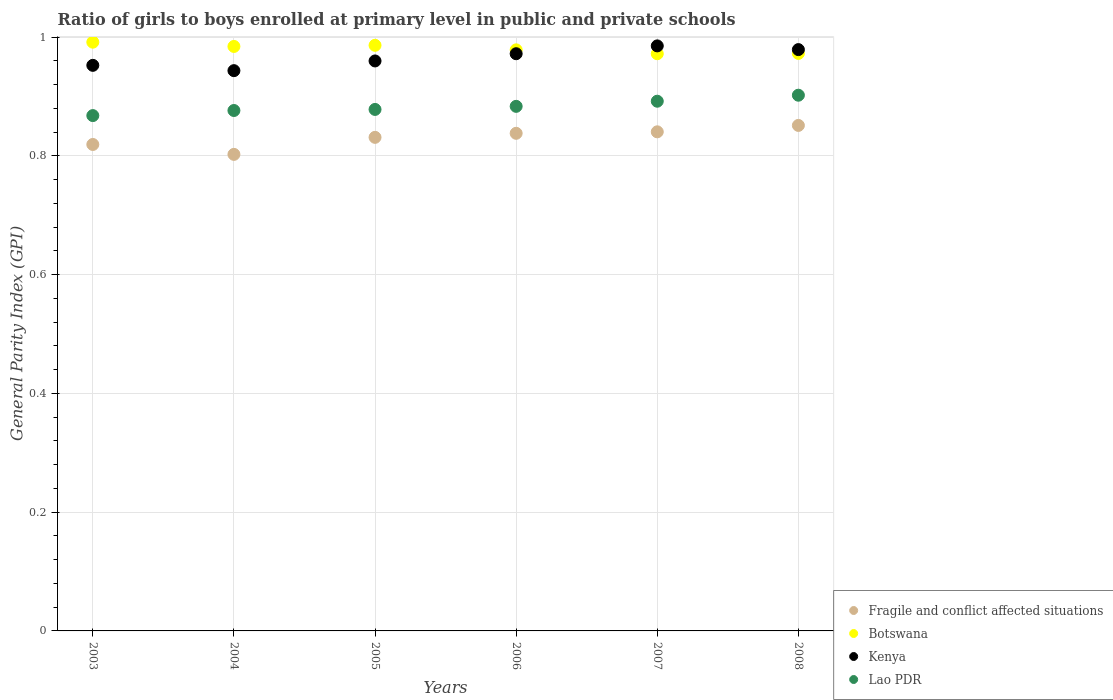What is the general parity index in Fragile and conflict affected situations in 2006?
Your answer should be compact. 0.84. Across all years, what is the maximum general parity index in Lao PDR?
Offer a terse response. 0.9. Across all years, what is the minimum general parity index in Botswana?
Keep it short and to the point. 0.97. In which year was the general parity index in Fragile and conflict affected situations maximum?
Make the answer very short. 2008. In which year was the general parity index in Botswana minimum?
Your response must be concise. 2007. What is the total general parity index in Lao PDR in the graph?
Provide a short and direct response. 5.3. What is the difference between the general parity index in Kenya in 2006 and that in 2007?
Keep it short and to the point. -0.01. What is the difference between the general parity index in Fragile and conflict affected situations in 2006 and the general parity index in Botswana in 2003?
Offer a terse response. -0.15. What is the average general parity index in Botswana per year?
Give a very brief answer. 0.98. In the year 2007, what is the difference between the general parity index in Kenya and general parity index in Botswana?
Ensure brevity in your answer.  0.01. What is the ratio of the general parity index in Kenya in 2005 to that in 2007?
Your answer should be compact. 0.97. Is the general parity index in Lao PDR in 2005 less than that in 2008?
Keep it short and to the point. Yes. What is the difference between the highest and the second highest general parity index in Botswana?
Your answer should be very brief. 0.01. What is the difference between the highest and the lowest general parity index in Lao PDR?
Provide a succinct answer. 0.03. In how many years, is the general parity index in Kenya greater than the average general parity index in Kenya taken over all years?
Your answer should be compact. 3. Is the sum of the general parity index in Botswana in 2006 and 2008 greater than the maximum general parity index in Kenya across all years?
Ensure brevity in your answer.  Yes. Is it the case that in every year, the sum of the general parity index in Kenya and general parity index in Lao PDR  is greater than the sum of general parity index in Fragile and conflict affected situations and general parity index in Botswana?
Make the answer very short. No. Is it the case that in every year, the sum of the general parity index in Fragile and conflict affected situations and general parity index in Kenya  is greater than the general parity index in Lao PDR?
Make the answer very short. Yes. Does the general parity index in Fragile and conflict affected situations monotonically increase over the years?
Make the answer very short. No. Is the general parity index in Kenya strictly greater than the general parity index in Lao PDR over the years?
Make the answer very short. Yes. How many dotlines are there?
Ensure brevity in your answer.  4. Are the values on the major ticks of Y-axis written in scientific E-notation?
Give a very brief answer. No. Does the graph contain grids?
Provide a short and direct response. Yes. What is the title of the graph?
Your answer should be very brief. Ratio of girls to boys enrolled at primary level in public and private schools. Does "Haiti" appear as one of the legend labels in the graph?
Provide a succinct answer. No. What is the label or title of the X-axis?
Give a very brief answer. Years. What is the label or title of the Y-axis?
Keep it short and to the point. General Parity Index (GPI). What is the General Parity Index (GPI) in Fragile and conflict affected situations in 2003?
Ensure brevity in your answer.  0.82. What is the General Parity Index (GPI) of Botswana in 2003?
Your response must be concise. 0.99. What is the General Parity Index (GPI) in Kenya in 2003?
Keep it short and to the point. 0.95. What is the General Parity Index (GPI) of Lao PDR in 2003?
Offer a very short reply. 0.87. What is the General Parity Index (GPI) in Fragile and conflict affected situations in 2004?
Ensure brevity in your answer.  0.8. What is the General Parity Index (GPI) of Botswana in 2004?
Your answer should be compact. 0.98. What is the General Parity Index (GPI) in Kenya in 2004?
Provide a short and direct response. 0.94. What is the General Parity Index (GPI) of Lao PDR in 2004?
Make the answer very short. 0.88. What is the General Parity Index (GPI) in Fragile and conflict affected situations in 2005?
Offer a terse response. 0.83. What is the General Parity Index (GPI) in Botswana in 2005?
Give a very brief answer. 0.99. What is the General Parity Index (GPI) in Kenya in 2005?
Provide a short and direct response. 0.96. What is the General Parity Index (GPI) of Lao PDR in 2005?
Provide a short and direct response. 0.88. What is the General Parity Index (GPI) in Fragile and conflict affected situations in 2006?
Make the answer very short. 0.84. What is the General Parity Index (GPI) of Botswana in 2006?
Your answer should be very brief. 0.98. What is the General Parity Index (GPI) of Kenya in 2006?
Your answer should be very brief. 0.97. What is the General Parity Index (GPI) of Lao PDR in 2006?
Your answer should be very brief. 0.88. What is the General Parity Index (GPI) of Fragile and conflict affected situations in 2007?
Make the answer very short. 0.84. What is the General Parity Index (GPI) in Botswana in 2007?
Offer a very short reply. 0.97. What is the General Parity Index (GPI) of Kenya in 2007?
Offer a terse response. 0.99. What is the General Parity Index (GPI) in Lao PDR in 2007?
Your response must be concise. 0.89. What is the General Parity Index (GPI) in Fragile and conflict affected situations in 2008?
Make the answer very short. 0.85. What is the General Parity Index (GPI) in Botswana in 2008?
Offer a terse response. 0.97. What is the General Parity Index (GPI) of Kenya in 2008?
Make the answer very short. 0.98. What is the General Parity Index (GPI) in Lao PDR in 2008?
Your response must be concise. 0.9. Across all years, what is the maximum General Parity Index (GPI) in Fragile and conflict affected situations?
Offer a very short reply. 0.85. Across all years, what is the maximum General Parity Index (GPI) of Botswana?
Offer a terse response. 0.99. Across all years, what is the maximum General Parity Index (GPI) of Kenya?
Ensure brevity in your answer.  0.99. Across all years, what is the maximum General Parity Index (GPI) in Lao PDR?
Ensure brevity in your answer.  0.9. Across all years, what is the minimum General Parity Index (GPI) of Fragile and conflict affected situations?
Your answer should be compact. 0.8. Across all years, what is the minimum General Parity Index (GPI) in Botswana?
Your answer should be compact. 0.97. Across all years, what is the minimum General Parity Index (GPI) in Kenya?
Offer a very short reply. 0.94. Across all years, what is the minimum General Parity Index (GPI) of Lao PDR?
Offer a very short reply. 0.87. What is the total General Parity Index (GPI) of Fragile and conflict affected situations in the graph?
Make the answer very short. 4.98. What is the total General Parity Index (GPI) of Botswana in the graph?
Your response must be concise. 5.89. What is the total General Parity Index (GPI) of Kenya in the graph?
Provide a short and direct response. 5.79. What is the total General Parity Index (GPI) of Lao PDR in the graph?
Your answer should be compact. 5.3. What is the difference between the General Parity Index (GPI) in Fragile and conflict affected situations in 2003 and that in 2004?
Provide a short and direct response. 0.02. What is the difference between the General Parity Index (GPI) of Botswana in 2003 and that in 2004?
Provide a short and direct response. 0.01. What is the difference between the General Parity Index (GPI) of Kenya in 2003 and that in 2004?
Your answer should be compact. 0.01. What is the difference between the General Parity Index (GPI) in Lao PDR in 2003 and that in 2004?
Offer a very short reply. -0.01. What is the difference between the General Parity Index (GPI) of Fragile and conflict affected situations in 2003 and that in 2005?
Provide a short and direct response. -0.01. What is the difference between the General Parity Index (GPI) in Botswana in 2003 and that in 2005?
Make the answer very short. 0.01. What is the difference between the General Parity Index (GPI) of Kenya in 2003 and that in 2005?
Your answer should be very brief. -0.01. What is the difference between the General Parity Index (GPI) in Lao PDR in 2003 and that in 2005?
Provide a succinct answer. -0.01. What is the difference between the General Parity Index (GPI) of Fragile and conflict affected situations in 2003 and that in 2006?
Your response must be concise. -0.02. What is the difference between the General Parity Index (GPI) of Botswana in 2003 and that in 2006?
Your response must be concise. 0.01. What is the difference between the General Parity Index (GPI) of Kenya in 2003 and that in 2006?
Your answer should be compact. -0.02. What is the difference between the General Parity Index (GPI) of Lao PDR in 2003 and that in 2006?
Provide a succinct answer. -0.02. What is the difference between the General Parity Index (GPI) of Fragile and conflict affected situations in 2003 and that in 2007?
Make the answer very short. -0.02. What is the difference between the General Parity Index (GPI) in Botswana in 2003 and that in 2007?
Give a very brief answer. 0.02. What is the difference between the General Parity Index (GPI) in Kenya in 2003 and that in 2007?
Your answer should be very brief. -0.03. What is the difference between the General Parity Index (GPI) of Lao PDR in 2003 and that in 2007?
Ensure brevity in your answer.  -0.02. What is the difference between the General Parity Index (GPI) of Fragile and conflict affected situations in 2003 and that in 2008?
Provide a short and direct response. -0.03. What is the difference between the General Parity Index (GPI) in Botswana in 2003 and that in 2008?
Provide a succinct answer. 0.02. What is the difference between the General Parity Index (GPI) in Kenya in 2003 and that in 2008?
Give a very brief answer. -0.03. What is the difference between the General Parity Index (GPI) of Lao PDR in 2003 and that in 2008?
Provide a succinct answer. -0.03. What is the difference between the General Parity Index (GPI) of Fragile and conflict affected situations in 2004 and that in 2005?
Your answer should be compact. -0.03. What is the difference between the General Parity Index (GPI) of Botswana in 2004 and that in 2005?
Keep it short and to the point. -0. What is the difference between the General Parity Index (GPI) in Kenya in 2004 and that in 2005?
Provide a short and direct response. -0.02. What is the difference between the General Parity Index (GPI) in Lao PDR in 2004 and that in 2005?
Give a very brief answer. -0. What is the difference between the General Parity Index (GPI) in Fragile and conflict affected situations in 2004 and that in 2006?
Ensure brevity in your answer.  -0.04. What is the difference between the General Parity Index (GPI) in Botswana in 2004 and that in 2006?
Offer a very short reply. 0.01. What is the difference between the General Parity Index (GPI) in Kenya in 2004 and that in 2006?
Give a very brief answer. -0.03. What is the difference between the General Parity Index (GPI) in Lao PDR in 2004 and that in 2006?
Give a very brief answer. -0.01. What is the difference between the General Parity Index (GPI) in Fragile and conflict affected situations in 2004 and that in 2007?
Your response must be concise. -0.04. What is the difference between the General Parity Index (GPI) of Botswana in 2004 and that in 2007?
Your answer should be compact. 0.01. What is the difference between the General Parity Index (GPI) of Kenya in 2004 and that in 2007?
Keep it short and to the point. -0.04. What is the difference between the General Parity Index (GPI) of Lao PDR in 2004 and that in 2007?
Provide a short and direct response. -0.02. What is the difference between the General Parity Index (GPI) in Fragile and conflict affected situations in 2004 and that in 2008?
Give a very brief answer. -0.05. What is the difference between the General Parity Index (GPI) of Botswana in 2004 and that in 2008?
Ensure brevity in your answer.  0.01. What is the difference between the General Parity Index (GPI) in Kenya in 2004 and that in 2008?
Offer a terse response. -0.04. What is the difference between the General Parity Index (GPI) in Lao PDR in 2004 and that in 2008?
Keep it short and to the point. -0.03. What is the difference between the General Parity Index (GPI) of Fragile and conflict affected situations in 2005 and that in 2006?
Your answer should be compact. -0.01. What is the difference between the General Parity Index (GPI) of Botswana in 2005 and that in 2006?
Provide a short and direct response. 0.01. What is the difference between the General Parity Index (GPI) of Kenya in 2005 and that in 2006?
Offer a terse response. -0.01. What is the difference between the General Parity Index (GPI) of Lao PDR in 2005 and that in 2006?
Provide a succinct answer. -0.01. What is the difference between the General Parity Index (GPI) of Fragile and conflict affected situations in 2005 and that in 2007?
Give a very brief answer. -0.01. What is the difference between the General Parity Index (GPI) of Botswana in 2005 and that in 2007?
Give a very brief answer. 0.01. What is the difference between the General Parity Index (GPI) in Kenya in 2005 and that in 2007?
Keep it short and to the point. -0.03. What is the difference between the General Parity Index (GPI) of Lao PDR in 2005 and that in 2007?
Your response must be concise. -0.01. What is the difference between the General Parity Index (GPI) in Fragile and conflict affected situations in 2005 and that in 2008?
Make the answer very short. -0.02. What is the difference between the General Parity Index (GPI) of Botswana in 2005 and that in 2008?
Provide a short and direct response. 0.01. What is the difference between the General Parity Index (GPI) in Kenya in 2005 and that in 2008?
Provide a short and direct response. -0.02. What is the difference between the General Parity Index (GPI) of Lao PDR in 2005 and that in 2008?
Provide a succinct answer. -0.02. What is the difference between the General Parity Index (GPI) in Fragile and conflict affected situations in 2006 and that in 2007?
Your answer should be compact. -0. What is the difference between the General Parity Index (GPI) in Botswana in 2006 and that in 2007?
Your answer should be compact. 0.01. What is the difference between the General Parity Index (GPI) of Kenya in 2006 and that in 2007?
Provide a short and direct response. -0.01. What is the difference between the General Parity Index (GPI) of Lao PDR in 2006 and that in 2007?
Ensure brevity in your answer.  -0.01. What is the difference between the General Parity Index (GPI) of Fragile and conflict affected situations in 2006 and that in 2008?
Offer a very short reply. -0.01. What is the difference between the General Parity Index (GPI) of Botswana in 2006 and that in 2008?
Give a very brief answer. 0.01. What is the difference between the General Parity Index (GPI) of Kenya in 2006 and that in 2008?
Your answer should be very brief. -0.01. What is the difference between the General Parity Index (GPI) in Lao PDR in 2006 and that in 2008?
Your answer should be very brief. -0.02. What is the difference between the General Parity Index (GPI) of Fragile and conflict affected situations in 2007 and that in 2008?
Your answer should be compact. -0.01. What is the difference between the General Parity Index (GPI) in Botswana in 2007 and that in 2008?
Give a very brief answer. -0. What is the difference between the General Parity Index (GPI) of Kenya in 2007 and that in 2008?
Offer a terse response. 0.01. What is the difference between the General Parity Index (GPI) of Lao PDR in 2007 and that in 2008?
Your answer should be compact. -0.01. What is the difference between the General Parity Index (GPI) of Fragile and conflict affected situations in 2003 and the General Parity Index (GPI) of Botswana in 2004?
Provide a short and direct response. -0.17. What is the difference between the General Parity Index (GPI) of Fragile and conflict affected situations in 2003 and the General Parity Index (GPI) of Kenya in 2004?
Your answer should be compact. -0.12. What is the difference between the General Parity Index (GPI) of Fragile and conflict affected situations in 2003 and the General Parity Index (GPI) of Lao PDR in 2004?
Your response must be concise. -0.06. What is the difference between the General Parity Index (GPI) in Botswana in 2003 and the General Parity Index (GPI) in Kenya in 2004?
Provide a short and direct response. 0.05. What is the difference between the General Parity Index (GPI) in Botswana in 2003 and the General Parity Index (GPI) in Lao PDR in 2004?
Provide a short and direct response. 0.12. What is the difference between the General Parity Index (GPI) in Kenya in 2003 and the General Parity Index (GPI) in Lao PDR in 2004?
Provide a short and direct response. 0.08. What is the difference between the General Parity Index (GPI) in Fragile and conflict affected situations in 2003 and the General Parity Index (GPI) in Botswana in 2005?
Provide a short and direct response. -0.17. What is the difference between the General Parity Index (GPI) in Fragile and conflict affected situations in 2003 and the General Parity Index (GPI) in Kenya in 2005?
Offer a terse response. -0.14. What is the difference between the General Parity Index (GPI) of Fragile and conflict affected situations in 2003 and the General Parity Index (GPI) of Lao PDR in 2005?
Offer a very short reply. -0.06. What is the difference between the General Parity Index (GPI) of Botswana in 2003 and the General Parity Index (GPI) of Kenya in 2005?
Ensure brevity in your answer.  0.03. What is the difference between the General Parity Index (GPI) in Botswana in 2003 and the General Parity Index (GPI) in Lao PDR in 2005?
Provide a short and direct response. 0.11. What is the difference between the General Parity Index (GPI) in Kenya in 2003 and the General Parity Index (GPI) in Lao PDR in 2005?
Provide a succinct answer. 0.07. What is the difference between the General Parity Index (GPI) in Fragile and conflict affected situations in 2003 and the General Parity Index (GPI) in Botswana in 2006?
Give a very brief answer. -0.16. What is the difference between the General Parity Index (GPI) in Fragile and conflict affected situations in 2003 and the General Parity Index (GPI) in Kenya in 2006?
Ensure brevity in your answer.  -0.15. What is the difference between the General Parity Index (GPI) in Fragile and conflict affected situations in 2003 and the General Parity Index (GPI) in Lao PDR in 2006?
Provide a short and direct response. -0.06. What is the difference between the General Parity Index (GPI) of Botswana in 2003 and the General Parity Index (GPI) of Kenya in 2006?
Provide a succinct answer. 0.02. What is the difference between the General Parity Index (GPI) in Botswana in 2003 and the General Parity Index (GPI) in Lao PDR in 2006?
Ensure brevity in your answer.  0.11. What is the difference between the General Parity Index (GPI) of Kenya in 2003 and the General Parity Index (GPI) of Lao PDR in 2006?
Ensure brevity in your answer.  0.07. What is the difference between the General Parity Index (GPI) of Fragile and conflict affected situations in 2003 and the General Parity Index (GPI) of Botswana in 2007?
Offer a very short reply. -0.15. What is the difference between the General Parity Index (GPI) of Fragile and conflict affected situations in 2003 and the General Parity Index (GPI) of Kenya in 2007?
Your answer should be very brief. -0.17. What is the difference between the General Parity Index (GPI) in Fragile and conflict affected situations in 2003 and the General Parity Index (GPI) in Lao PDR in 2007?
Your response must be concise. -0.07. What is the difference between the General Parity Index (GPI) in Botswana in 2003 and the General Parity Index (GPI) in Kenya in 2007?
Give a very brief answer. 0.01. What is the difference between the General Parity Index (GPI) of Botswana in 2003 and the General Parity Index (GPI) of Lao PDR in 2007?
Provide a short and direct response. 0.1. What is the difference between the General Parity Index (GPI) in Kenya in 2003 and the General Parity Index (GPI) in Lao PDR in 2007?
Offer a very short reply. 0.06. What is the difference between the General Parity Index (GPI) of Fragile and conflict affected situations in 2003 and the General Parity Index (GPI) of Botswana in 2008?
Provide a succinct answer. -0.15. What is the difference between the General Parity Index (GPI) of Fragile and conflict affected situations in 2003 and the General Parity Index (GPI) of Kenya in 2008?
Your answer should be very brief. -0.16. What is the difference between the General Parity Index (GPI) of Fragile and conflict affected situations in 2003 and the General Parity Index (GPI) of Lao PDR in 2008?
Make the answer very short. -0.08. What is the difference between the General Parity Index (GPI) in Botswana in 2003 and the General Parity Index (GPI) in Kenya in 2008?
Provide a short and direct response. 0.01. What is the difference between the General Parity Index (GPI) in Botswana in 2003 and the General Parity Index (GPI) in Lao PDR in 2008?
Provide a succinct answer. 0.09. What is the difference between the General Parity Index (GPI) in Kenya in 2003 and the General Parity Index (GPI) in Lao PDR in 2008?
Your response must be concise. 0.05. What is the difference between the General Parity Index (GPI) of Fragile and conflict affected situations in 2004 and the General Parity Index (GPI) of Botswana in 2005?
Offer a terse response. -0.18. What is the difference between the General Parity Index (GPI) of Fragile and conflict affected situations in 2004 and the General Parity Index (GPI) of Kenya in 2005?
Offer a very short reply. -0.16. What is the difference between the General Parity Index (GPI) in Fragile and conflict affected situations in 2004 and the General Parity Index (GPI) in Lao PDR in 2005?
Make the answer very short. -0.08. What is the difference between the General Parity Index (GPI) in Botswana in 2004 and the General Parity Index (GPI) in Kenya in 2005?
Provide a succinct answer. 0.02. What is the difference between the General Parity Index (GPI) in Botswana in 2004 and the General Parity Index (GPI) in Lao PDR in 2005?
Your answer should be compact. 0.11. What is the difference between the General Parity Index (GPI) of Kenya in 2004 and the General Parity Index (GPI) of Lao PDR in 2005?
Keep it short and to the point. 0.07. What is the difference between the General Parity Index (GPI) in Fragile and conflict affected situations in 2004 and the General Parity Index (GPI) in Botswana in 2006?
Offer a terse response. -0.18. What is the difference between the General Parity Index (GPI) in Fragile and conflict affected situations in 2004 and the General Parity Index (GPI) in Kenya in 2006?
Make the answer very short. -0.17. What is the difference between the General Parity Index (GPI) of Fragile and conflict affected situations in 2004 and the General Parity Index (GPI) of Lao PDR in 2006?
Your answer should be compact. -0.08. What is the difference between the General Parity Index (GPI) in Botswana in 2004 and the General Parity Index (GPI) in Kenya in 2006?
Your response must be concise. 0.01. What is the difference between the General Parity Index (GPI) in Botswana in 2004 and the General Parity Index (GPI) in Lao PDR in 2006?
Your response must be concise. 0.1. What is the difference between the General Parity Index (GPI) of Kenya in 2004 and the General Parity Index (GPI) of Lao PDR in 2006?
Offer a terse response. 0.06. What is the difference between the General Parity Index (GPI) of Fragile and conflict affected situations in 2004 and the General Parity Index (GPI) of Botswana in 2007?
Offer a terse response. -0.17. What is the difference between the General Parity Index (GPI) in Fragile and conflict affected situations in 2004 and the General Parity Index (GPI) in Kenya in 2007?
Your response must be concise. -0.18. What is the difference between the General Parity Index (GPI) of Fragile and conflict affected situations in 2004 and the General Parity Index (GPI) of Lao PDR in 2007?
Offer a very short reply. -0.09. What is the difference between the General Parity Index (GPI) in Botswana in 2004 and the General Parity Index (GPI) in Kenya in 2007?
Your response must be concise. -0. What is the difference between the General Parity Index (GPI) in Botswana in 2004 and the General Parity Index (GPI) in Lao PDR in 2007?
Make the answer very short. 0.09. What is the difference between the General Parity Index (GPI) in Kenya in 2004 and the General Parity Index (GPI) in Lao PDR in 2007?
Your response must be concise. 0.05. What is the difference between the General Parity Index (GPI) in Fragile and conflict affected situations in 2004 and the General Parity Index (GPI) in Botswana in 2008?
Offer a very short reply. -0.17. What is the difference between the General Parity Index (GPI) in Fragile and conflict affected situations in 2004 and the General Parity Index (GPI) in Kenya in 2008?
Provide a short and direct response. -0.18. What is the difference between the General Parity Index (GPI) of Fragile and conflict affected situations in 2004 and the General Parity Index (GPI) of Lao PDR in 2008?
Keep it short and to the point. -0.1. What is the difference between the General Parity Index (GPI) in Botswana in 2004 and the General Parity Index (GPI) in Kenya in 2008?
Offer a very short reply. 0.01. What is the difference between the General Parity Index (GPI) of Botswana in 2004 and the General Parity Index (GPI) of Lao PDR in 2008?
Keep it short and to the point. 0.08. What is the difference between the General Parity Index (GPI) in Kenya in 2004 and the General Parity Index (GPI) in Lao PDR in 2008?
Your answer should be very brief. 0.04. What is the difference between the General Parity Index (GPI) in Fragile and conflict affected situations in 2005 and the General Parity Index (GPI) in Botswana in 2006?
Your answer should be very brief. -0.15. What is the difference between the General Parity Index (GPI) of Fragile and conflict affected situations in 2005 and the General Parity Index (GPI) of Kenya in 2006?
Make the answer very short. -0.14. What is the difference between the General Parity Index (GPI) of Fragile and conflict affected situations in 2005 and the General Parity Index (GPI) of Lao PDR in 2006?
Ensure brevity in your answer.  -0.05. What is the difference between the General Parity Index (GPI) of Botswana in 2005 and the General Parity Index (GPI) of Kenya in 2006?
Provide a succinct answer. 0.01. What is the difference between the General Parity Index (GPI) of Botswana in 2005 and the General Parity Index (GPI) of Lao PDR in 2006?
Keep it short and to the point. 0.1. What is the difference between the General Parity Index (GPI) in Kenya in 2005 and the General Parity Index (GPI) in Lao PDR in 2006?
Your answer should be compact. 0.08. What is the difference between the General Parity Index (GPI) of Fragile and conflict affected situations in 2005 and the General Parity Index (GPI) of Botswana in 2007?
Your response must be concise. -0.14. What is the difference between the General Parity Index (GPI) of Fragile and conflict affected situations in 2005 and the General Parity Index (GPI) of Kenya in 2007?
Provide a succinct answer. -0.15. What is the difference between the General Parity Index (GPI) of Fragile and conflict affected situations in 2005 and the General Parity Index (GPI) of Lao PDR in 2007?
Make the answer very short. -0.06. What is the difference between the General Parity Index (GPI) in Botswana in 2005 and the General Parity Index (GPI) in Lao PDR in 2007?
Your answer should be compact. 0.09. What is the difference between the General Parity Index (GPI) in Kenya in 2005 and the General Parity Index (GPI) in Lao PDR in 2007?
Offer a very short reply. 0.07. What is the difference between the General Parity Index (GPI) in Fragile and conflict affected situations in 2005 and the General Parity Index (GPI) in Botswana in 2008?
Provide a succinct answer. -0.14. What is the difference between the General Parity Index (GPI) in Fragile and conflict affected situations in 2005 and the General Parity Index (GPI) in Kenya in 2008?
Your answer should be compact. -0.15. What is the difference between the General Parity Index (GPI) of Fragile and conflict affected situations in 2005 and the General Parity Index (GPI) of Lao PDR in 2008?
Offer a terse response. -0.07. What is the difference between the General Parity Index (GPI) of Botswana in 2005 and the General Parity Index (GPI) of Kenya in 2008?
Provide a succinct answer. 0.01. What is the difference between the General Parity Index (GPI) in Botswana in 2005 and the General Parity Index (GPI) in Lao PDR in 2008?
Your answer should be compact. 0.08. What is the difference between the General Parity Index (GPI) in Kenya in 2005 and the General Parity Index (GPI) in Lao PDR in 2008?
Make the answer very short. 0.06. What is the difference between the General Parity Index (GPI) in Fragile and conflict affected situations in 2006 and the General Parity Index (GPI) in Botswana in 2007?
Your response must be concise. -0.13. What is the difference between the General Parity Index (GPI) in Fragile and conflict affected situations in 2006 and the General Parity Index (GPI) in Kenya in 2007?
Your response must be concise. -0.15. What is the difference between the General Parity Index (GPI) in Fragile and conflict affected situations in 2006 and the General Parity Index (GPI) in Lao PDR in 2007?
Keep it short and to the point. -0.05. What is the difference between the General Parity Index (GPI) in Botswana in 2006 and the General Parity Index (GPI) in Kenya in 2007?
Provide a short and direct response. -0.01. What is the difference between the General Parity Index (GPI) in Botswana in 2006 and the General Parity Index (GPI) in Lao PDR in 2007?
Make the answer very short. 0.09. What is the difference between the General Parity Index (GPI) in Kenya in 2006 and the General Parity Index (GPI) in Lao PDR in 2007?
Offer a very short reply. 0.08. What is the difference between the General Parity Index (GPI) of Fragile and conflict affected situations in 2006 and the General Parity Index (GPI) of Botswana in 2008?
Offer a terse response. -0.13. What is the difference between the General Parity Index (GPI) of Fragile and conflict affected situations in 2006 and the General Parity Index (GPI) of Kenya in 2008?
Keep it short and to the point. -0.14. What is the difference between the General Parity Index (GPI) in Fragile and conflict affected situations in 2006 and the General Parity Index (GPI) in Lao PDR in 2008?
Provide a short and direct response. -0.06. What is the difference between the General Parity Index (GPI) of Botswana in 2006 and the General Parity Index (GPI) of Kenya in 2008?
Provide a succinct answer. -0. What is the difference between the General Parity Index (GPI) in Botswana in 2006 and the General Parity Index (GPI) in Lao PDR in 2008?
Give a very brief answer. 0.08. What is the difference between the General Parity Index (GPI) in Kenya in 2006 and the General Parity Index (GPI) in Lao PDR in 2008?
Keep it short and to the point. 0.07. What is the difference between the General Parity Index (GPI) of Fragile and conflict affected situations in 2007 and the General Parity Index (GPI) of Botswana in 2008?
Offer a terse response. -0.13. What is the difference between the General Parity Index (GPI) in Fragile and conflict affected situations in 2007 and the General Parity Index (GPI) in Kenya in 2008?
Ensure brevity in your answer.  -0.14. What is the difference between the General Parity Index (GPI) in Fragile and conflict affected situations in 2007 and the General Parity Index (GPI) in Lao PDR in 2008?
Provide a short and direct response. -0.06. What is the difference between the General Parity Index (GPI) in Botswana in 2007 and the General Parity Index (GPI) in Kenya in 2008?
Your answer should be very brief. -0.01. What is the difference between the General Parity Index (GPI) in Botswana in 2007 and the General Parity Index (GPI) in Lao PDR in 2008?
Offer a very short reply. 0.07. What is the difference between the General Parity Index (GPI) in Kenya in 2007 and the General Parity Index (GPI) in Lao PDR in 2008?
Give a very brief answer. 0.08. What is the average General Parity Index (GPI) in Fragile and conflict affected situations per year?
Offer a terse response. 0.83. What is the average General Parity Index (GPI) of Botswana per year?
Offer a terse response. 0.98. What is the average General Parity Index (GPI) of Kenya per year?
Offer a very short reply. 0.97. What is the average General Parity Index (GPI) of Lao PDR per year?
Make the answer very short. 0.88. In the year 2003, what is the difference between the General Parity Index (GPI) of Fragile and conflict affected situations and General Parity Index (GPI) of Botswana?
Your answer should be very brief. -0.17. In the year 2003, what is the difference between the General Parity Index (GPI) in Fragile and conflict affected situations and General Parity Index (GPI) in Kenya?
Keep it short and to the point. -0.13. In the year 2003, what is the difference between the General Parity Index (GPI) in Fragile and conflict affected situations and General Parity Index (GPI) in Lao PDR?
Your answer should be compact. -0.05. In the year 2003, what is the difference between the General Parity Index (GPI) in Botswana and General Parity Index (GPI) in Kenya?
Provide a short and direct response. 0.04. In the year 2003, what is the difference between the General Parity Index (GPI) in Botswana and General Parity Index (GPI) in Lao PDR?
Provide a succinct answer. 0.12. In the year 2003, what is the difference between the General Parity Index (GPI) in Kenya and General Parity Index (GPI) in Lao PDR?
Ensure brevity in your answer.  0.08. In the year 2004, what is the difference between the General Parity Index (GPI) in Fragile and conflict affected situations and General Parity Index (GPI) in Botswana?
Your answer should be very brief. -0.18. In the year 2004, what is the difference between the General Parity Index (GPI) of Fragile and conflict affected situations and General Parity Index (GPI) of Kenya?
Make the answer very short. -0.14. In the year 2004, what is the difference between the General Parity Index (GPI) in Fragile and conflict affected situations and General Parity Index (GPI) in Lao PDR?
Your response must be concise. -0.07. In the year 2004, what is the difference between the General Parity Index (GPI) in Botswana and General Parity Index (GPI) in Kenya?
Your response must be concise. 0.04. In the year 2004, what is the difference between the General Parity Index (GPI) in Botswana and General Parity Index (GPI) in Lao PDR?
Make the answer very short. 0.11. In the year 2004, what is the difference between the General Parity Index (GPI) of Kenya and General Parity Index (GPI) of Lao PDR?
Make the answer very short. 0.07. In the year 2005, what is the difference between the General Parity Index (GPI) of Fragile and conflict affected situations and General Parity Index (GPI) of Botswana?
Ensure brevity in your answer.  -0.15. In the year 2005, what is the difference between the General Parity Index (GPI) of Fragile and conflict affected situations and General Parity Index (GPI) of Kenya?
Provide a short and direct response. -0.13. In the year 2005, what is the difference between the General Parity Index (GPI) of Fragile and conflict affected situations and General Parity Index (GPI) of Lao PDR?
Keep it short and to the point. -0.05. In the year 2005, what is the difference between the General Parity Index (GPI) in Botswana and General Parity Index (GPI) in Kenya?
Your response must be concise. 0.03. In the year 2005, what is the difference between the General Parity Index (GPI) in Botswana and General Parity Index (GPI) in Lao PDR?
Make the answer very short. 0.11. In the year 2005, what is the difference between the General Parity Index (GPI) in Kenya and General Parity Index (GPI) in Lao PDR?
Offer a terse response. 0.08. In the year 2006, what is the difference between the General Parity Index (GPI) of Fragile and conflict affected situations and General Parity Index (GPI) of Botswana?
Ensure brevity in your answer.  -0.14. In the year 2006, what is the difference between the General Parity Index (GPI) of Fragile and conflict affected situations and General Parity Index (GPI) of Kenya?
Ensure brevity in your answer.  -0.13. In the year 2006, what is the difference between the General Parity Index (GPI) in Fragile and conflict affected situations and General Parity Index (GPI) in Lao PDR?
Make the answer very short. -0.05. In the year 2006, what is the difference between the General Parity Index (GPI) of Botswana and General Parity Index (GPI) of Kenya?
Provide a succinct answer. 0.01. In the year 2006, what is the difference between the General Parity Index (GPI) in Botswana and General Parity Index (GPI) in Lao PDR?
Give a very brief answer. 0.1. In the year 2006, what is the difference between the General Parity Index (GPI) in Kenya and General Parity Index (GPI) in Lao PDR?
Make the answer very short. 0.09. In the year 2007, what is the difference between the General Parity Index (GPI) in Fragile and conflict affected situations and General Parity Index (GPI) in Botswana?
Offer a very short reply. -0.13. In the year 2007, what is the difference between the General Parity Index (GPI) in Fragile and conflict affected situations and General Parity Index (GPI) in Kenya?
Provide a succinct answer. -0.14. In the year 2007, what is the difference between the General Parity Index (GPI) in Fragile and conflict affected situations and General Parity Index (GPI) in Lao PDR?
Your answer should be very brief. -0.05. In the year 2007, what is the difference between the General Parity Index (GPI) in Botswana and General Parity Index (GPI) in Kenya?
Give a very brief answer. -0.01. In the year 2007, what is the difference between the General Parity Index (GPI) of Kenya and General Parity Index (GPI) of Lao PDR?
Your answer should be very brief. 0.09. In the year 2008, what is the difference between the General Parity Index (GPI) in Fragile and conflict affected situations and General Parity Index (GPI) in Botswana?
Keep it short and to the point. -0.12. In the year 2008, what is the difference between the General Parity Index (GPI) of Fragile and conflict affected situations and General Parity Index (GPI) of Kenya?
Give a very brief answer. -0.13. In the year 2008, what is the difference between the General Parity Index (GPI) in Fragile and conflict affected situations and General Parity Index (GPI) in Lao PDR?
Your response must be concise. -0.05. In the year 2008, what is the difference between the General Parity Index (GPI) in Botswana and General Parity Index (GPI) in Kenya?
Provide a succinct answer. -0.01. In the year 2008, what is the difference between the General Parity Index (GPI) of Botswana and General Parity Index (GPI) of Lao PDR?
Your response must be concise. 0.07. In the year 2008, what is the difference between the General Parity Index (GPI) of Kenya and General Parity Index (GPI) of Lao PDR?
Offer a very short reply. 0.08. What is the ratio of the General Parity Index (GPI) of Fragile and conflict affected situations in 2003 to that in 2004?
Make the answer very short. 1.02. What is the ratio of the General Parity Index (GPI) of Botswana in 2003 to that in 2004?
Provide a succinct answer. 1.01. What is the ratio of the General Parity Index (GPI) of Kenya in 2003 to that in 2004?
Provide a short and direct response. 1.01. What is the ratio of the General Parity Index (GPI) of Lao PDR in 2003 to that in 2004?
Provide a short and direct response. 0.99. What is the ratio of the General Parity Index (GPI) in Fragile and conflict affected situations in 2003 to that in 2005?
Ensure brevity in your answer.  0.99. What is the ratio of the General Parity Index (GPI) in Kenya in 2003 to that in 2005?
Make the answer very short. 0.99. What is the ratio of the General Parity Index (GPI) of Lao PDR in 2003 to that in 2005?
Keep it short and to the point. 0.99. What is the ratio of the General Parity Index (GPI) of Fragile and conflict affected situations in 2003 to that in 2006?
Your answer should be compact. 0.98. What is the ratio of the General Parity Index (GPI) of Botswana in 2003 to that in 2006?
Ensure brevity in your answer.  1.01. What is the ratio of the General Parity Index (GPI) in Kenya in 2003 to that in 2006?
Make the answer very short. 0.98. What is the ratio of the General Parity Index (GPI) in Lao PDR in 2003 to that in 2006?
Offer a very short reply. 0.98. What is the ratio of the General Parity Index (GPI) of Fragile and conflict affected situations in 2003 to that in 2007?
Your answer should be very brief. 0.97. What is the ratio of the General Parity Index (GPI) in Kenya in 2003 to that in 2007?
Your answer should be compact. 0.97. What is the ratio of the General Parity Index (GPI) in Lao PDR in 2003 to that in 2007?
Offer a terse response. 0.97. What is the ratio of the General Parity Index (GPI) in Fragile and conflict affected situations in 2003 to that in 2008?
Keep it short and to the point. 0.96. What is the ratio of the General Parity Index (GPI) in Botswana in 2003 to that in 2008?
Your response must be concise. 1.02. What is the ratio of the General Parity Index (GPI) of Kenya in 2003 to that in 2008?
Your answer should be compact. 0.97. What is the ratio of the General Parity Index (GPI) of Lao PDR in 2003 to that in 2008?
Your response must be concise. 0.96. What is the ratio of the General Parity Index (GPI) in Fragile and conflict affected situations in 2004 to that in 2005?
Offer a very short reply. 0.97. What is the ratio of the General Parity Index (GPI) of Botswana in 2004 to that in 2005?
Give a very brief answer. 1. What is the ratio of the General Parity Index (GPI) in Lao PDR in 2004 to that in 2005?
Provide a succinct answer. 1. What is the ratio of the General Parity Index (GPI) of Fragile and conflict affected situations in 2004 to that in 2006?
Make the answer very short. 0.96. What is the ratio of the General Parity Index (GPI) of Botswana in 2004 to that in 2006?
Offer a terse response. 1.01. What is the ratio of the General Parity Index (GPI) in Kenya in 2004 to that in 2006?
Make the answer very short. 0.97. What is the ratio of the General Parity Index (GPI) of Fragile and conflict affected situations in 2004 to that in 2007?
Your answer should be compact. 0.95. What is the ratio of the General Parity Index (GPI) of Botswana in 2004 to that in 2007?
Your response must be concise. 1.01. What is the ratio of the General Parity Index (GPI) of Kenya in 2004 to that in 2007?
Offer a terse response. 0.96. What is the ratio of the General Parity Index (GPI) in Lao PDR in 2004 to that in 2007?
Keep it short and to the point. 0.98. What is the ratio of the General Parity Index (GPI) in Fragile and conflict affected situations in 2004 to that in 2008?
Offer a terse response. 0.94. What is the ratio of the General Parity Index (GPI) in Botswana in 2004 to that in 2008?
Your response must be concise. 1.01. What is the ratio of the General Parity Index (GPI) in Kenya in 2004 to that in 2008?
Keep it short and to the point. 0.96. What is the ratio of the General Parity Index (GPI) of Lao PDR in 2004 to that in 2008?
Make the answer very short. 0.97. What is the ratio of the General Parity Index (GPI) in Fragile and conflict affected situations in 2005 to that in 2006?
Offer a very short reply. 0.99. What is the ratio of the General Parity Index (GPI) in Kenya in 2005 to that in 2006?
Provide a short and direct response. 0.99. What is the ratio of the General Parity Index (GPI) in Fragile and conflict affected situations in 2005 to that in 2007?
Your answer should be very brief. 0.99. What is the ratio of the General Parity Index (GPI) of Botswana in 2005 to that in 2007?
Provide a short and direct response. 1.01. What is the ratio of the General Parity Index (GPI) in Kenya in 2005 to that in 2007?
Provide a succinct answer. 0.97. What is the ratio of the General Parity Index (GPI) in Lao PDR in 2005 to that in 2007?
Offer a very short reply. 0.98. What is the ratio of the General Parity Index (GPI) of Fragile and conflict affected situations in 2005 to that in 2008?
Provide a succinct answer. 0.98. What is the ratio of the General Parity Index (GPI) in Botswana in 2005 to that in 2008?
Your response must be concise. 1.01. What is the ratio of the General Parity Index (GPI) in Kenya in 2005 to that in 2008?
Keep it short and to the point. 0.98. What is the ratio of the General Parity Index (GPI) of Lao PDR in 2005 to that in 2008?
Ensure brevity in your answer.  0.97. What is the ratio of the General Parity Index (GPI) in Kenya in 2006 to that in 2007?
Your answer should be very brief. 0.99. What is the ratio of the General Parity Index (GPI) in Lao PDR in 2006 to that in 2007?
Ensure brevity in your answer.  0.99. What is the ratio of the General Parity Index (GPI) in Fragile and conflict affected situations in 2006 to that in 2008?
Your response must be concise. 0.98. What is the ratio of the General Parity Index (GPI) in Botswana in 2006 to that in 2008?
Provide a succinct answer. 1.01. What is the ratio of the General Parity Index (GPI) in Lao PDR in 2006 to that in 2008?
Your answer should be compact. 0.98. What is the ratio of the General Parity Index (GPI) in Fragile and conflict affected situations in 2007 to that in 2008?
Your response must be concise. 0.99. What is the ratio of the General Parity Index (GPI) in Botswana in 2007 to that in 2008?
Your answer should be very brief. 1. What is the ratio of the General Parity Index (GPI) of Kenya in 2007 to that in 2008?
Give a very brief answer. 1.01. What is the difference between the highest and the second highest General Parity Index (GPI) in Fragile and conflict affected situations?
Make the answer very short. 0.01. What is the difference between the highest and the second highest General Parity Index (GPI) of Botswana?
Offer a terse response. 0.01. What is the difference between the highest and the second highest General Parity Index (GPI) in Kenya?
Offer a terse response. 0.01. What is the difference between the highest and the second highest General Parity Index (GPI) of Lao PDR?
Offer a terse response. 0.01. What is the difference between the highest and the lowest General Parity Index (GPI) in Fragile and conflict affected situations?
Keep it short and to the point. 0.05. What is the difference between the highest and the lowest General Parity Index (GPI) in Botswana?
Your answer should be very brief. 0.02. What is the difference between the highest and the lowest General Parity Index (GPI) in Kenya?
Offer a terse response. 0.04. What is the difference between the highest and the lowest General Parity Index (GPI) in Lao PDR?
Your response must be concise. 0.03. 